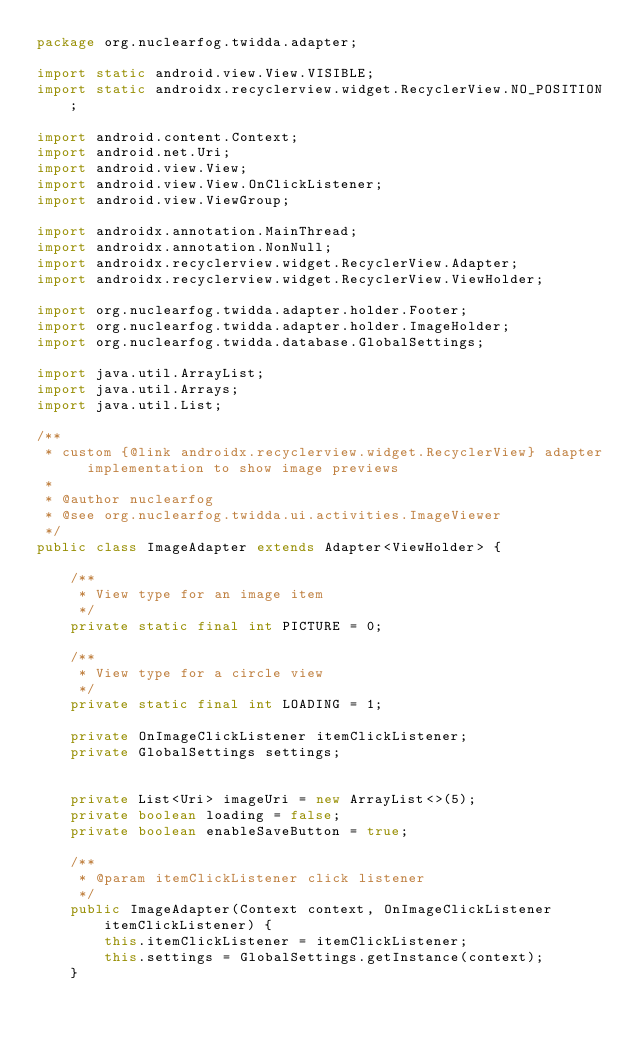Convert code to text. <code><loc_0><loc_0><loc_500><loc_500><_Java_>package org.nuclearfog.twidda.adapter;

import static android.view.View.VISIBLE;
import static androidx.recyclerview.widget.RecyclerView.NO_POSITION;

import android.content.Context;
import android.net.Uri;
import android.view.View;
import android.view.View.OnClickListener;
import android.view.ViewGroup;

import androidx.annotation.MainThread;
import androidx.annotation.NonNull;
import androidx.recyclerview.widget.RecyclerView.Adapter;
import androidx.recyclerview.widget.RecyclerView.ViewHolder;

import org.nuclearfog.twidda.adapter.holder.Footer;
import org.nuclearfog.twidda.adapter.holder.ImageHolder;
import org.nuclearfog.twidda.database.GlobalSettings;

import java.util.ArrayList;
import java.util.Arrays;
import java.util.List;

/**
 * custom {@link androidx.recyclerview.widget.RecyclerView} adapter implementation to show image previews
 *
 * @author nuclearfog
 * @see org.nuclearfog.twidda.ui.activities.ImageViewer
 */
public class ImageAdapter extends Adapter<ViewHolder> {

    /**
     * View type for an image item
     */
    private static final int PICTURE = 0;

    /**
     * View type for a circle view
     */
    private static final int LOADING = 1;

    private OnImageClickListener itemClickListener;
    private GlobalSettings settings;


    private List<Uri> imageUri = new ArrayList<>(5);
    private boolean loading = false;
    private boolean enableSaveButton = true;

    /**
     * @param itemClickListener click listener
     */
    public ImageAdapter(Context context, OnImageClickListener itemClickListener) {
        this.itemClickListener = itemClickListener;
        this.settings = GlobalSettings.getInstance(context);
    }

</code> 